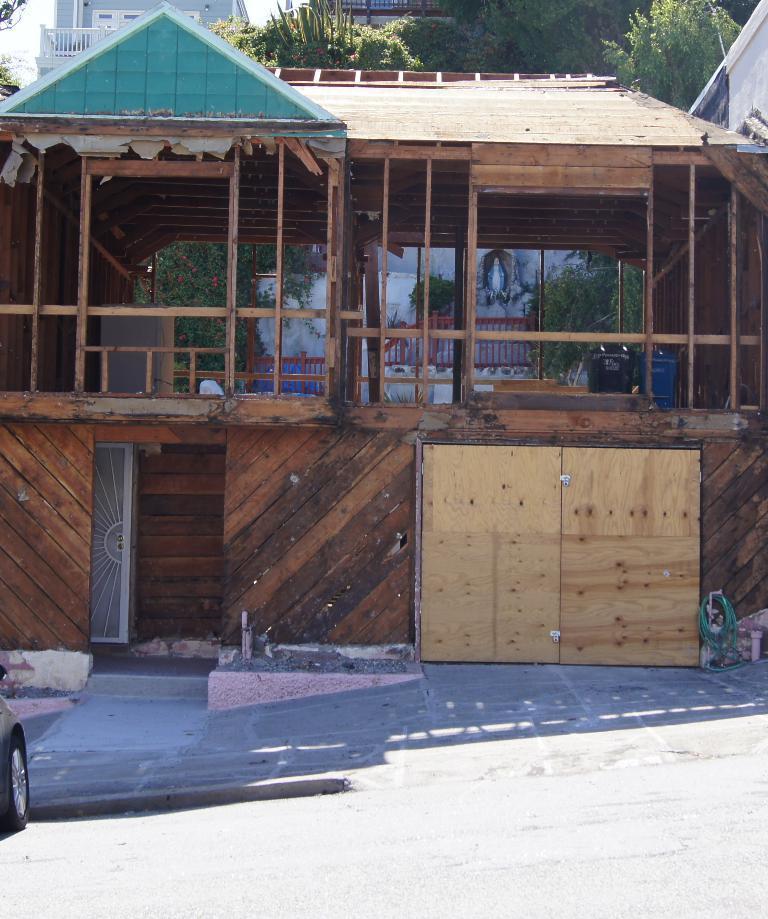Can you describe this image briefly? In the picture we can see a wooden house with railing and door and near to it, we can see a part of the vehicle wheel and behind the house we can see some plants and the part of the other house. 